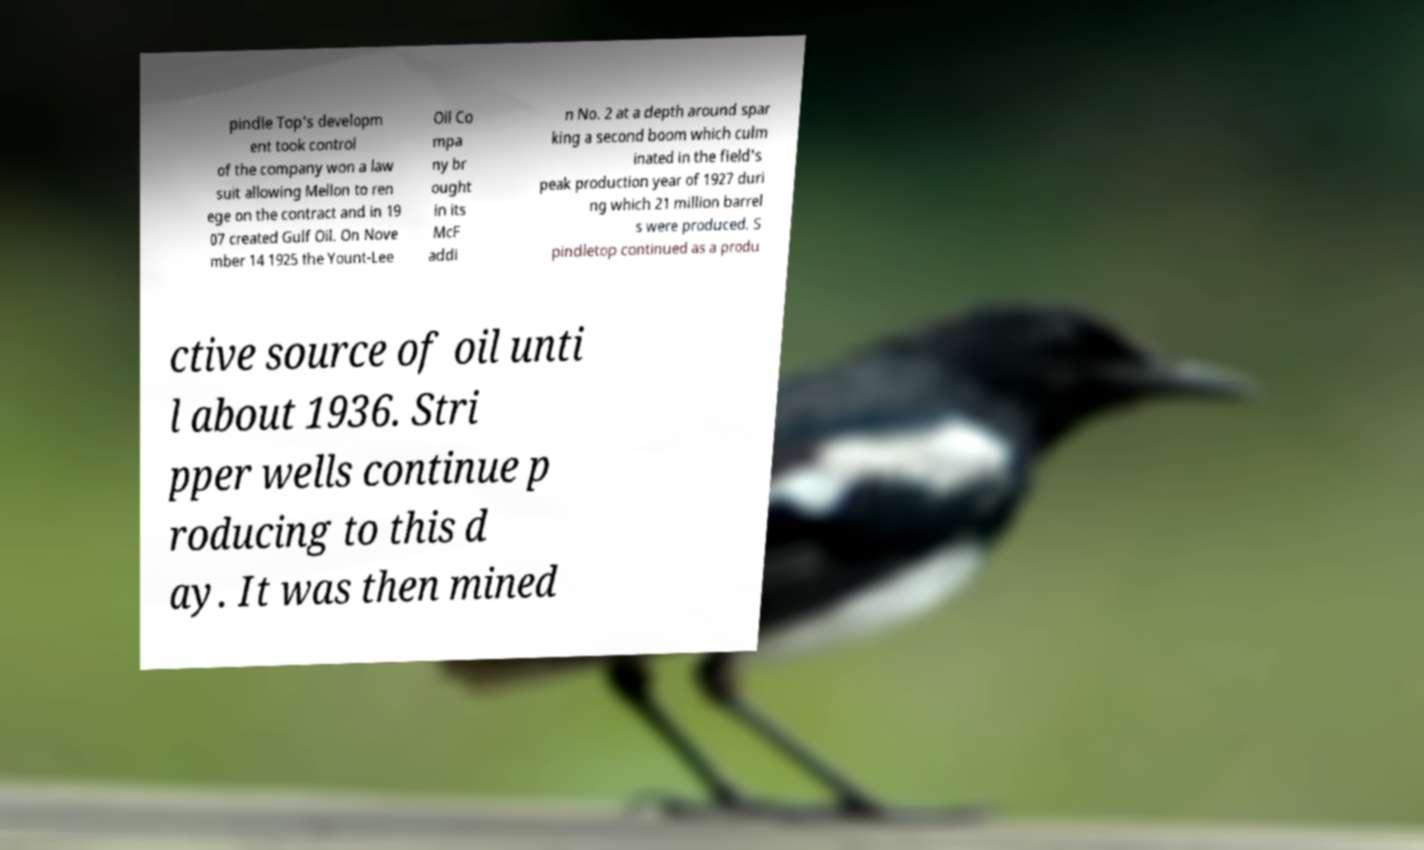There's text embedded in this image that I need extracted. Can you transcribe it verbatim? pindle Top's developm ent took control of the company won a law suit allowing Mellon to ren ege on the contract and in 19 07 created Gulf Oil. On Nove mber 14 1925 the Yount-Lee Oil Co mpa ny br ought in its McF addi n No. 2 at a depth around spar king a second boom which culm inated in the field's peak production year of 1927 duri ng which 21 million barrel s were produced. S pindletop continued as a produ ctive source of oil unti l about 1936. Stri pper wells continue p roducing to this d ay. It was then mined 